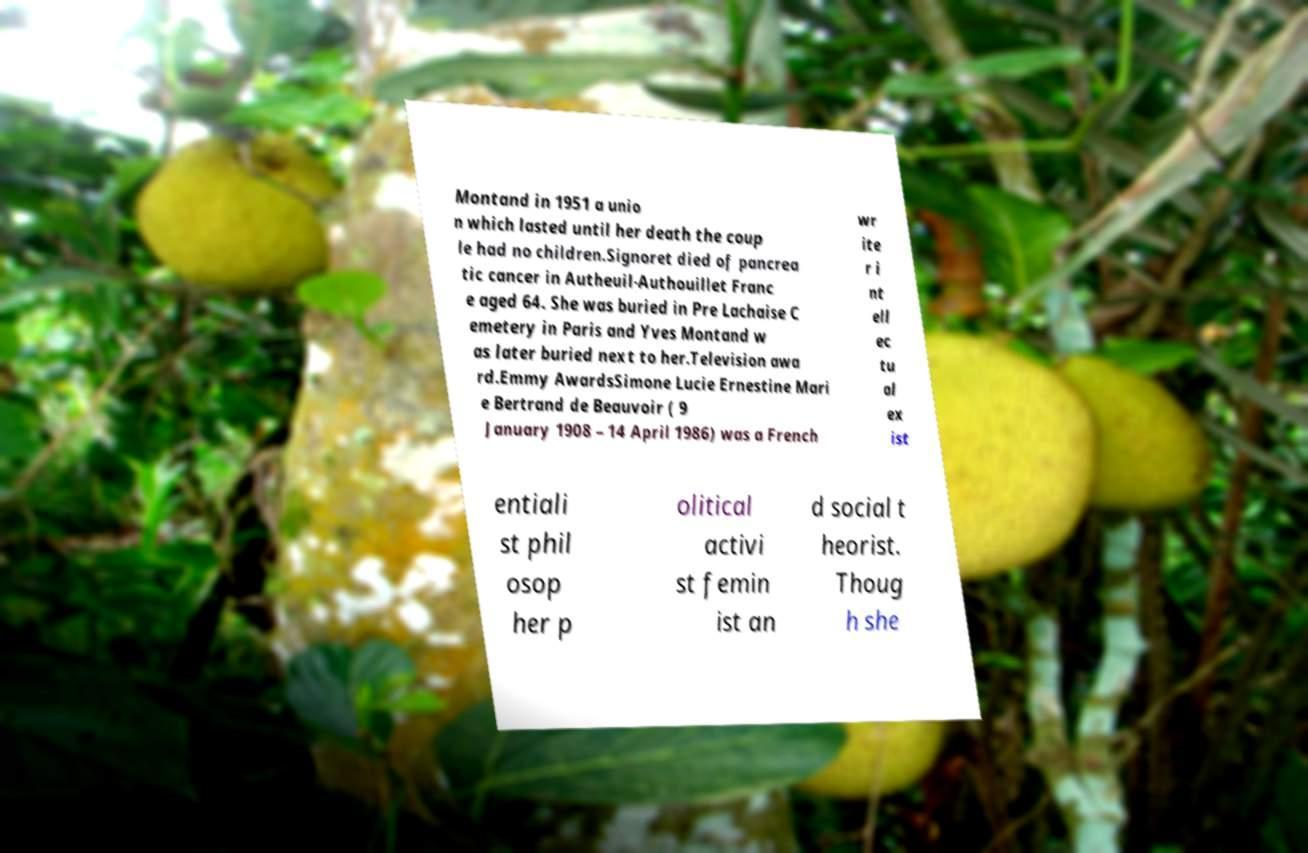Please identify and transcribe the text found in this image. Montand in 1951 a unio n which lasted until her death the coup le had no children.Signoret died of pancrea tic cancer in Autheuil-Authouillet Franc e aged 64. She was buried in Pre Lachaise C emetery in Paris and Yves Montand w as later buried next to her.Television awa rd.Emmy AwardsSimone Lucie Ernestine Mari e Bertrand de Beauvoir ( 9 January 1908 – 14 April 1986) was a French wr ite r i nt ell ec tu al ex ist entiali st phil osop her p olitical activi st femin ist an d social t heorist. Thoug h she 